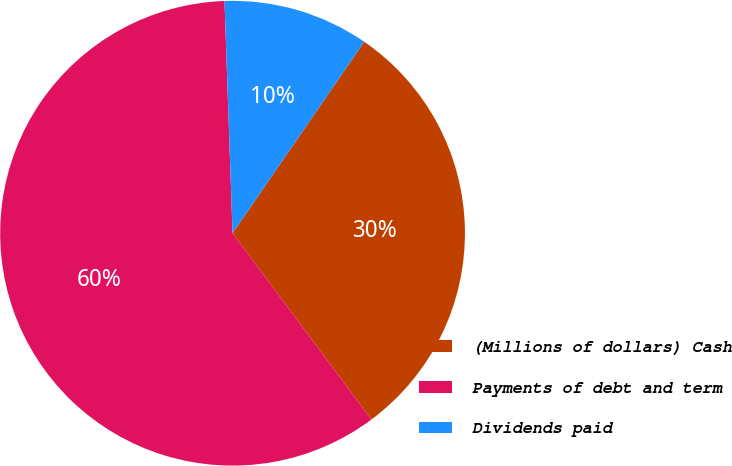Convert chart to OTSL. <chart><loc_0><loc_0><loc_500><loc_500><pie_chart><fcel>(Millions of dollars) Cash<fcel>Payments of debt and term<fcel>Dividends paid<nl><fcel>30.22%<fcel>59.63%<fcel>10.14%<nl></chart> 